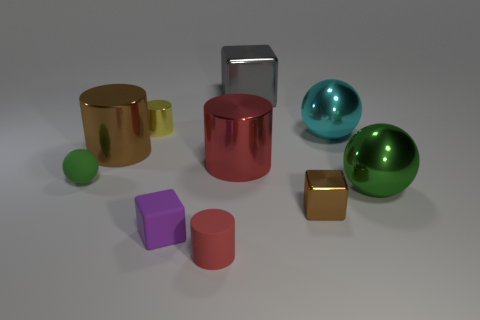How many green spheres must be subtracted to get 1 green spheres? 1 Subtract all tiny cubes. How many cubes are left? 1 Subtract 1 blocks. How many blocks are left? 2 Subtract all yellow cylinders. How many cylinders are left? 3 Subtract all cylinders. How many objects are left? 6 Add 2 tiny green things. How many tiny green things are left? 3 Add 7 green metallic balls. How many green metallic balls exist? 8 Subtract 0 yellow blocks. How many objects are left? 10 Subtract all yellow balls. Subtract all green cubes. How many balls are left? 3 Subtract all red cylinders. How many green balls are left? 2 